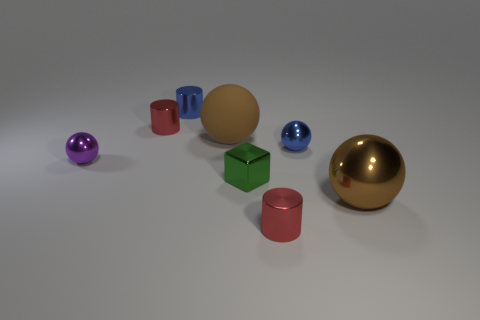Subtract all cyan spheres. Subtract all brown cubes. How many spheres are left? 4 Add 1 big red shiny spheres. How many objects exist? 9 Subtract all cylinders. How many objects are left? 5 Subtract all red metallic things. Subtract all small blue cylinders. How many objects are left? 5 Add 2 small red metal things. How many small red metal things are left? 4 Add 3 green metallic things. How many green metallic things exist? 4 Subtract 0 red spheres. How many objects are left? 8 